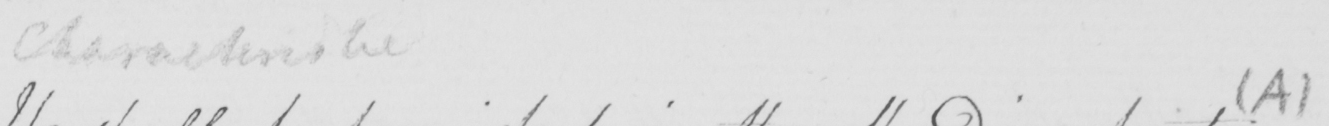Please transcribe the handwritten text in this image. Characteristic   ( A ) 